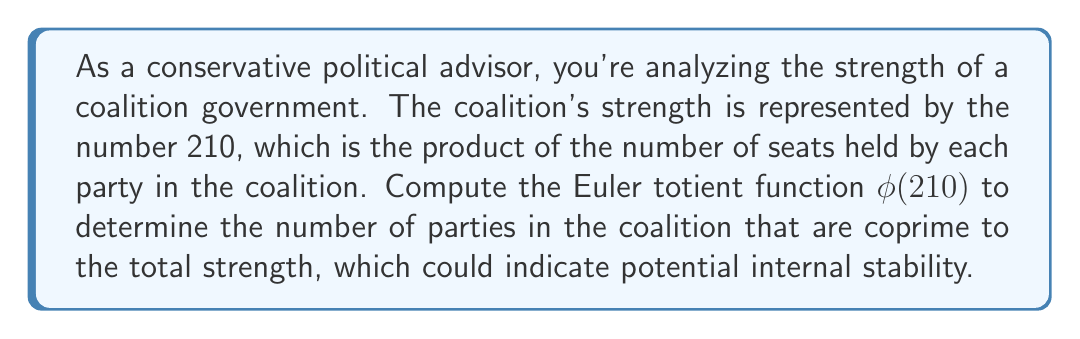Could you help me with this problem? To compute the Euler totient function $\phi(210)$, we follow these steps:

1) First, factor 210 into its prime factors:
   $210 = 2 \times 3 \times 5 \times 7$

2) The Euler totient function for a product of distinct primes is given by:
   $$\phi(n) = n \prod_{p|n} (1 - \frac{1}{p})$$
   where $p$ are the prime factors of $n$.

3) Applying this formula to 210:
   $$\phi(210) = 210 \times (1 - \frac{1}{2}) \times (1 - \frac{1}{3}) \times (1 - \frac{1}{5}) \times (1 - \frac{1}{7})$$

4) Simplify:
   $$\phi(210) = 210 \times \frac{1}{2} \times \frac{2}{3} \times \frac{4}{5} \times \frac{6}{7}$$

5) Calculate:
   $$\phi(210) = 210 \times \frac{48}{210} = 48$$

In political terms, this means that out of the 210 possible configurations of party seat distributions, 48 of them would result in a situation where the number of seats held by a party is coprime to the total, potentially indicating a more stable coalition arrangement.
Answer: $\phi(210) = 48$ 